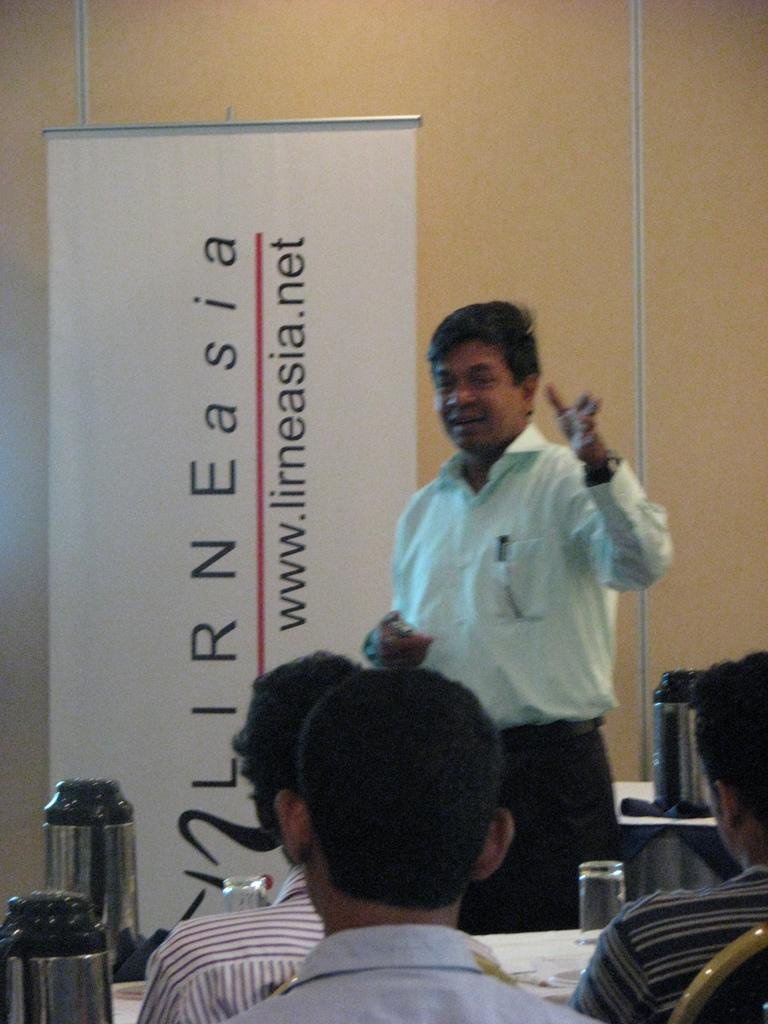<image>
Describe the image concisely. A man stands in front of a banner with the logo for Lirne Asia. 